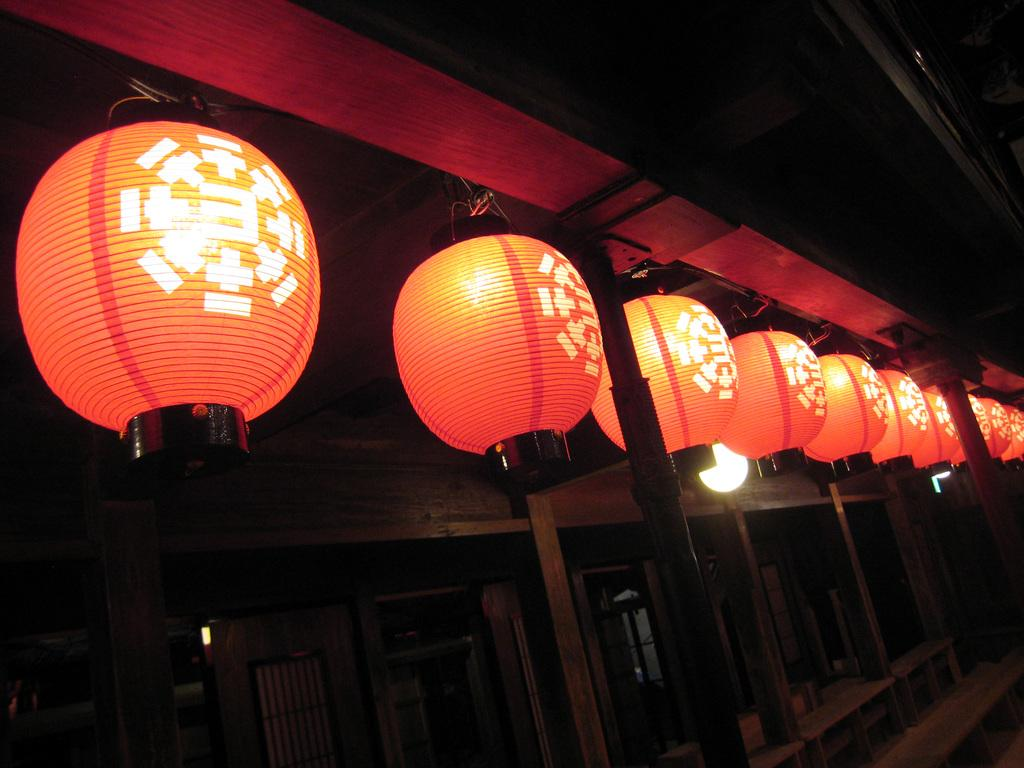What type of openings can be seen in the image? There are doors and windows in the image. What additional decorative element is present in the image? There is a paper lantern at the top of the image. What type of lizards can be seen crawling on the doors in the image? There are no lizards present in the image; it only features doors, windows, and a paper lantern. 